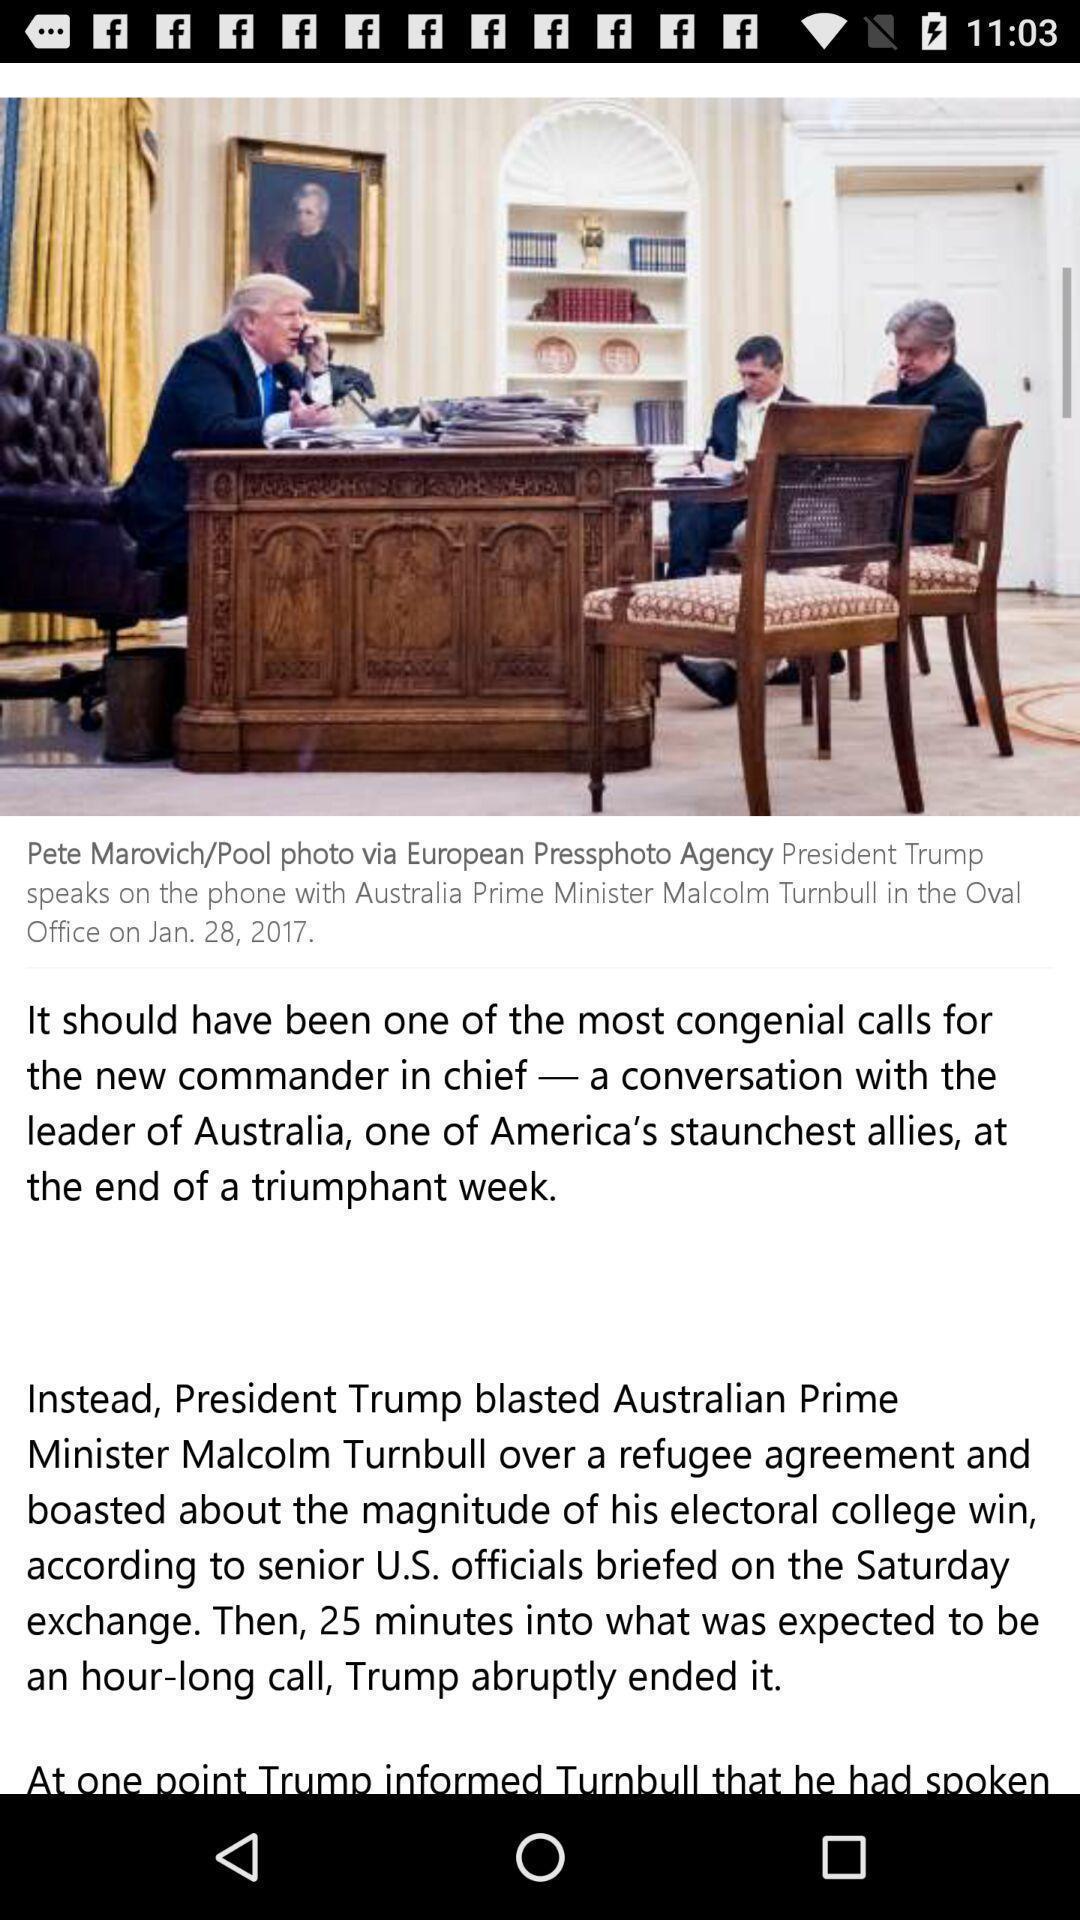Provide a textual representation of this image. Page showing an article in a news app. 